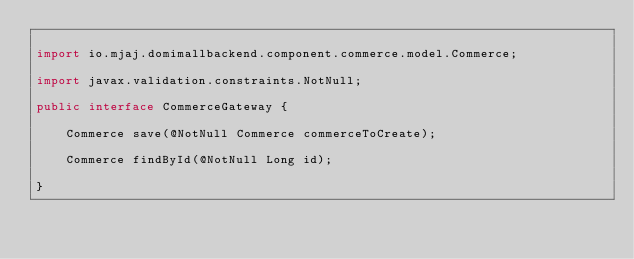<code> <loc_0><loc_0><loc_500><loc_500><_Java_>
import io.mjaj.domimallbackend.component.commerce.model.Commerce;

import javax.validation.constraints.NotNull;

public interface CommerceGateway {

    Commerce save(@NotNull Commerce commerceToCreate);

    Commerce findById(@NotNull Long id);

}
</code> 